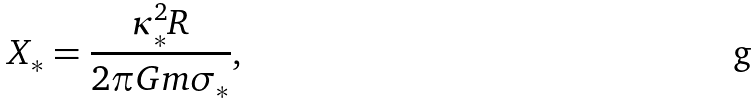<formula> <loc_0><loc_0><loc_500><loc_500>X _ { \ast } = \frac { { \kappa } _ { \ast } ^ { 2 } R } { 2 \pi G m { \sigma } _ { \ast } } ,</formula> 